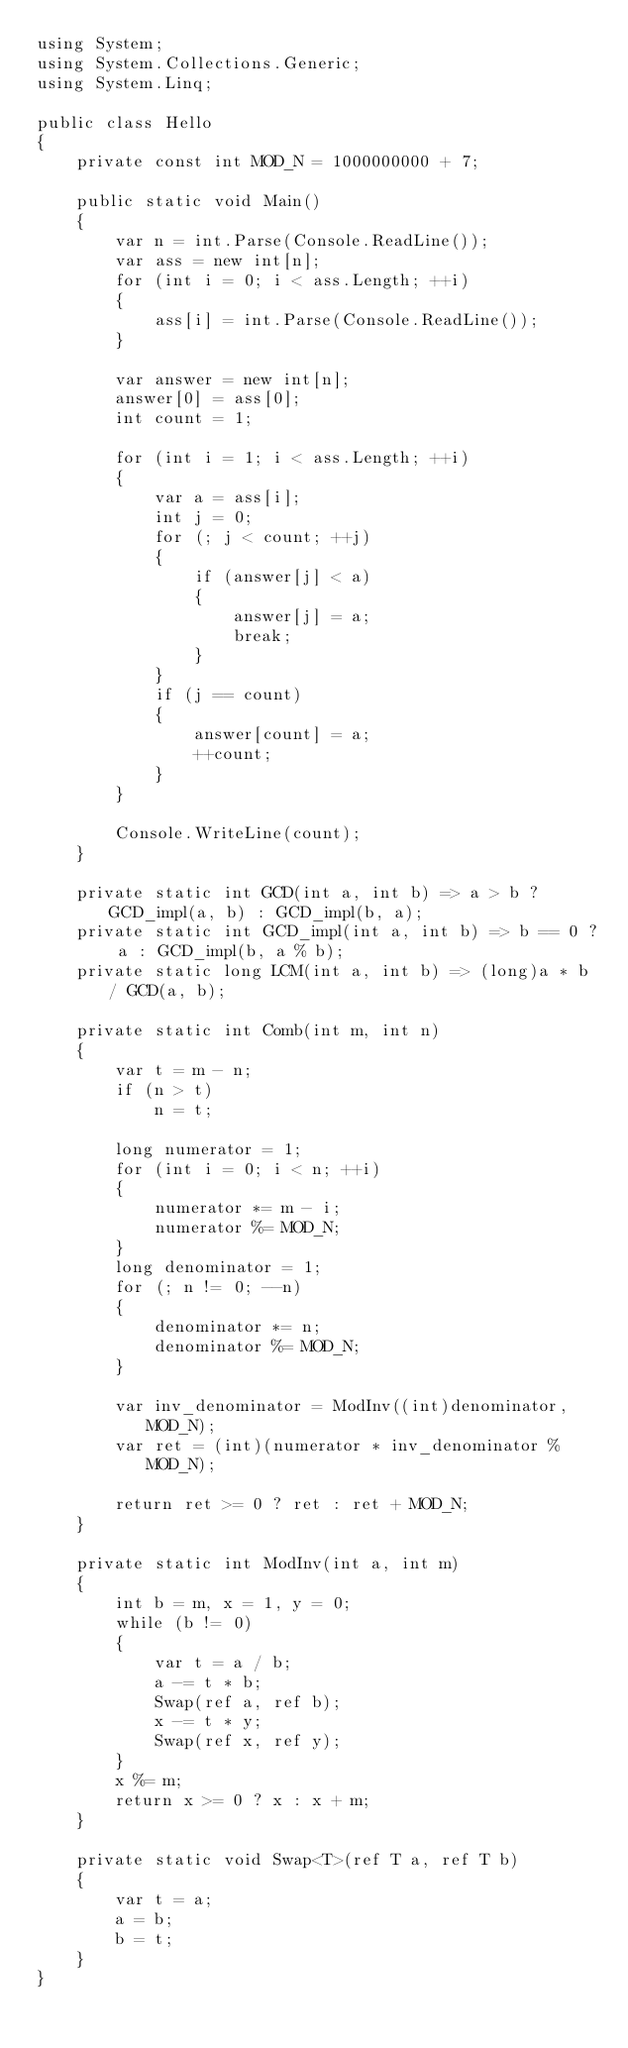<code> <loc_0><loc_0><loc_500><loc_500><_C#_>using System;
using System.Collections.Generic;
using System.Linq;

public class Hello
{
    private const int MOD_N = 1000000000 + 7;

    public static void Main()
    {
        var n = int.Parse(Console.ReadLine());
        var ass = new int[n];
        for (int i = 0; i < ass.Length; ++i)
        {
            ass[i] = int.Parse(Console.ReadLine());
        }

        var answer = new int[n];
        answer[0] = ass[0];
        int count = 1;

        for (int i = 1; i < ass.Length; ++i)
        {
            var a = ass[i];
            int j = 0;
            for (; j < count; ++j)
            {
                if (answer[j] < a)
                {
                    answer[j] = a;
                    break;
                }
            }
            if (j == count)
            {
                answer[count] = a;
                ++count;
            }
        }

        Console.WriteLine(count);
    }

    private static int GCD(int a, int b) => a > b ? GCD_impl(a, b) : GCD_impl(b, a);
    private static int GCD_impl(int a, int b) => b == 0 ? a : GCD_impl(b, a % b);
    private static long LCM(int a, int b) => (long)a * b / GCD(a, b);

    private static int Comb(int m, int n)
    {
        var t = m - n;
        if (n > t)
            n = t;

        long numerator = 1;
        for (int i = 0; i < n; ++i)
        {
            numerator *= m - i;
            numerator %= MOD_N;
        }
        long denominator = 1;
        for (; n != 0; --n)
        {
            denominator *= n;
            denominator %= MOD_N;
        }

        var inv_denominator = ModInv((int)denominator, MOD_N);
        var ret = (int)(numerator * inv_denominator % MOD_N);

        return ret >= 0 ? ret : ret + MOD_N;
    }

    private static int ModInv(int a, int m)
    {
        int b = m, x = 1, y = 0;
        while (b != 0)
        {
            var t = a / b;
            a -= t * b;
            Swap(ref a, ref b);
            x -= t * y;
            Swap(ref x, ref y);
        }
        x %= m;
        return x >= 0 ? x : x + m;
    }

    private static void Swap<T>(ref T a, ref T b)
    {
        var t = a;
        a = b;
        b = t;
    }
}
</code> 